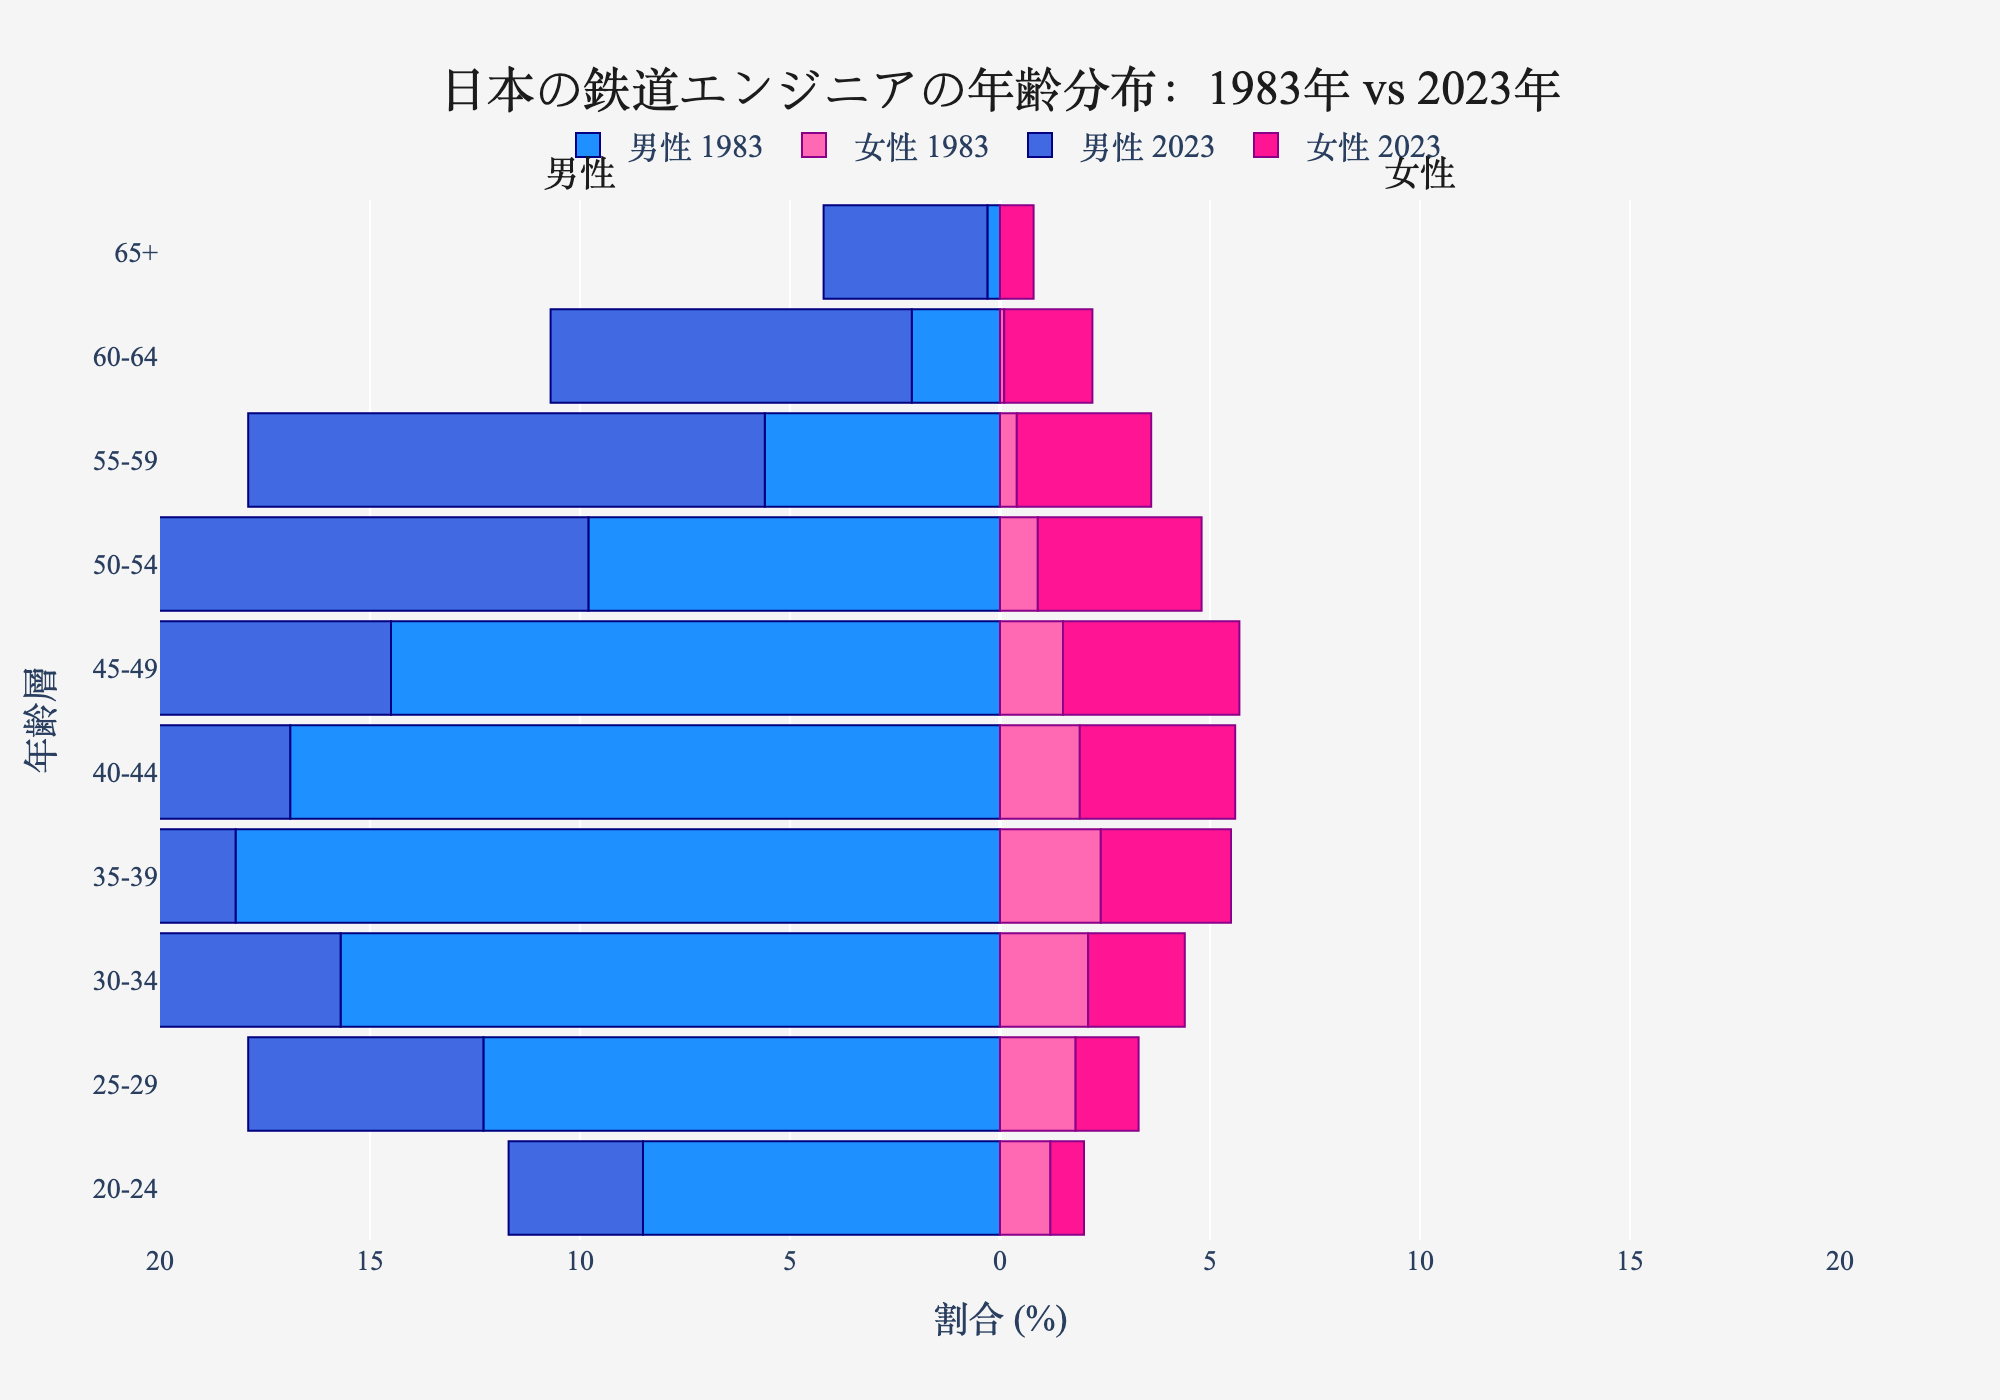what is the title of the plot? The title of the plot is usually found at the top and provides a summary of the graph's purpose. In this case, the title indicates the content and comparison involved in the plot.
Answer: 日本の鉄道エンジニアの年齢分布：1983年 vs 2023年 What age group has the highest percentage of male railway engineers in 2023? To determine this, look for the longest bar on the left side representing males in 2023, then check the age group it corresponds to.
Answer: 45-49 Which age group has seen the most significant increase in the percentage of female railway engineers from 1983 to 2023? Compare the length of the bars for each age group for females in 1983 and 2023. Identify the age group where the difference between 2023 and 1983 is the largest.
Answer: 45-49 In which age group has the percentage of male railway engineers decreased the most from 1983 to 2023? Compare the lengths of the bars for each age group for males in 1983 and 2023. The group with the most significant decrease will be the age group where the difference between 1983 and 2023 is the largest in the negative direction.
Answer: 35-39 What is the percentage of female railway engineers in the 55-59 age group in 1983? Look at the bar for females in the 55-59 age group in 1983 and read the value directly from the x-axis.
Answer: 0.4 What is the sum of the percentages of male railway engineers in the 40-44 and 45-49 age groups in 1983? Find the percentage values for males in both age groups in 1983, then add them together: 40-44 (16.9) + 45-49 (14.5).
Answer: 31.4 Which age group has a higher percentage of female railway engineers in 2023 compared to 1983 for the same group? Compare the heights of the bars for each age group for females in 1983 and 2023. Identify the groups where the bar for 2023 is higher than the bar for 1983.
Answer: All age groups How has the distribution of male railway engineers aged 30-34 changed from 1983 to 2023? Look at the bars representing the 30-34 age group for males in 1983 and 2023. Subtract the percentage for 1983 from the percentage for 2023 to analyze the change.
Answer: Decreased by 6.8 (15.7 in 1983 vs. 8.9 in 2023) In 2023, which age group has the lowest percentage of railway engineers, combining both males and females? Add the percentages for both males and females in each age group in 2023, then identify the group with the lowest total.
Answer: 20-24 What is the percentage difference between male and female railway engineers in the 50-54 age group in 2023? Find the percentages for both males and females in the 50-54 age group in 2023 and calculate their difference: 14.7 - 3.9.
Answer: 10.8 